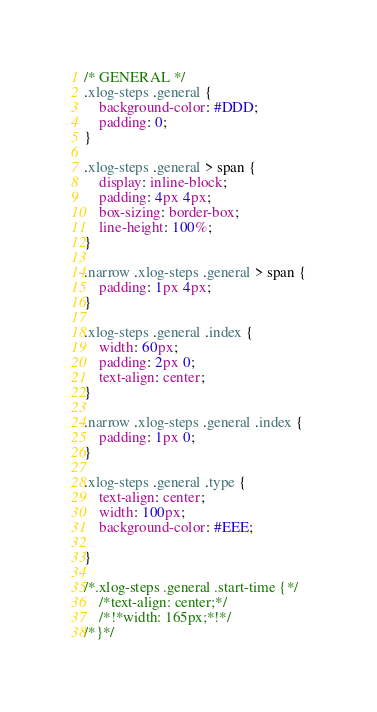<code> <loc_0><loc_0><loc_500><loc_500><_CSS_>/* GENERAL */
.xlog-steps .general {
    background-color: #DDD;
    padding: 0;
}

.xlog-steps .general > span {
    display: inline-block;
    padding: 4px 4px;
    box-sizing: border-box;
    line-height: 100%;
}

.narrow .xlog-steps .general > span {
    padding: 1px 4px;
}

.xlog-steps .general .index {
    width: 60px;
    padding: 2px 0;
    text-align: center;
}

.narrow .xlog-steps .general .index {
    padding: 1px 0;
}

.xlog-steps .general .type {
    text-align: center;
    width: 100px;
    background-color: #EEE;

}

/*.xlog-steps .general .start-time {*/
    /*text-align: center;*/
    /*!*width: 165px;*!*/
/*}*/
</code> 